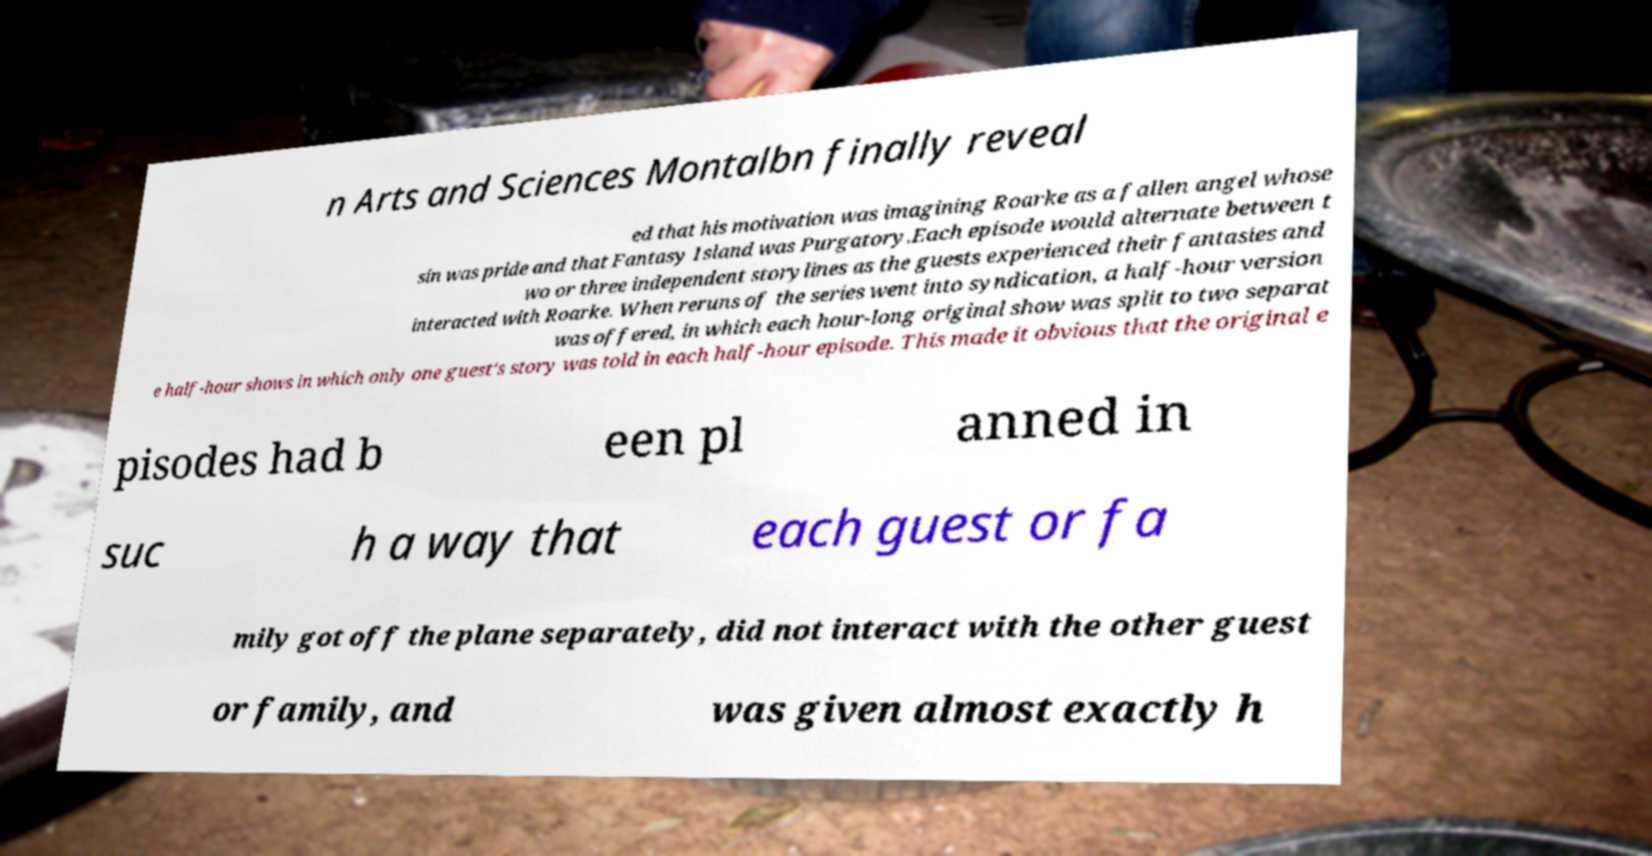Could you assist in decoding the text presented in this image and type it out clearly? n Arts and Sciences Montalbn finally reveal ed that his motivation was imagining Roarke as a fallen angel whose sin was pride and that Fantasy Island was Purgatory.Each episode would alternate between t wo or three independent storylines as the guests experienced their fantasies and interacted with Roarke. When reruns of the series went into syndication, a half-hour version was offered, in which each hour-long original show was split to two separat e half-hour shows in which only one guest's story was told in each half-hour episode. This made it obvious that the original e pisodes had b een pl anned in suc h a way that each guest or fa mily got off the plane separately, did not interact with the other guest or family, and was given almost exactly h 